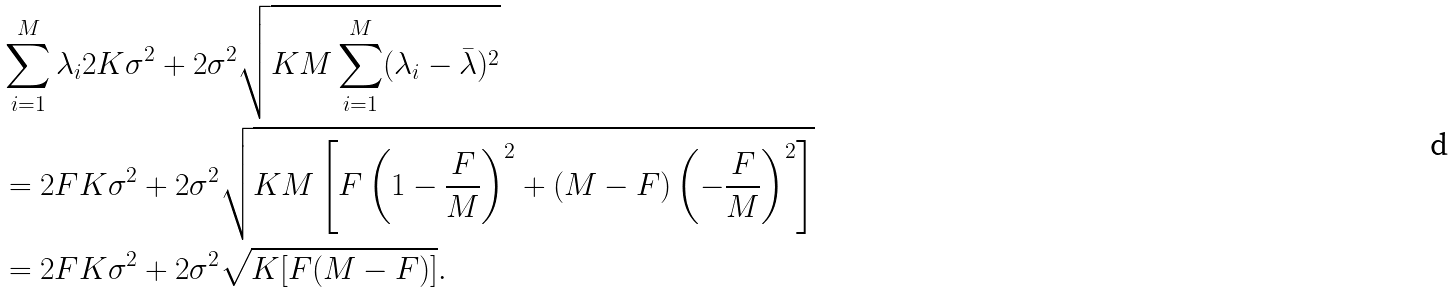<formula> <loc_0><loc_0><loc_500><loc_500>& \sum _ { i = 1 } ^ { M } \lambda _ { i } 2 K \sigma ^ { 2 } + 2 \sigma ^ { 2 } \sqrt { K M \sum _ { i = 1 } ^ { M } ( \lambda _ { i } - \bar { \lambda } ) ^ { 2 } } \\ & = 2 F K \sigma ^ { 2 } + 2 \sigma ^ { 2 } \sqrt { K M \left [ F \left ( 1 - \frac { F } { M } \right ) ^ { 2 } + ( M - F ) \left ( - \frac { F } { M } \right ) ^ { 2 } \right ] } \\ & = 2 F K \sigma ^ { 2 } + 2 \sigma ^ { 2 } \sqrt { K [ F ( M - F ) ] } .</formula> 